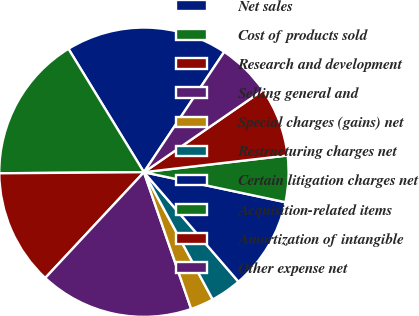Convert chart to OTSL. <chart><loc_0><loc_0><loc_500><loc_500><pie_chart><fcel>Net sales<fcel>Cost of products sold<fcel>Research and development<fcel>Selling general and<fcel>Special charges (gains) net<fcel>Restructuring charges net<fcel>Certain litigation charges net<fcel>Acquisition-related items<fcel>Amortization of intangible<fcel>Other expense net<nl><fcel>18.1%<fcel>16.38%<fcel>12.93%<fcel>17.24%<fcel>2.59%<fcel>3.45%<fcel>10.34%<fcel>5.17%<fcel>7.76%<fcel>6.03%<nl></chart> 